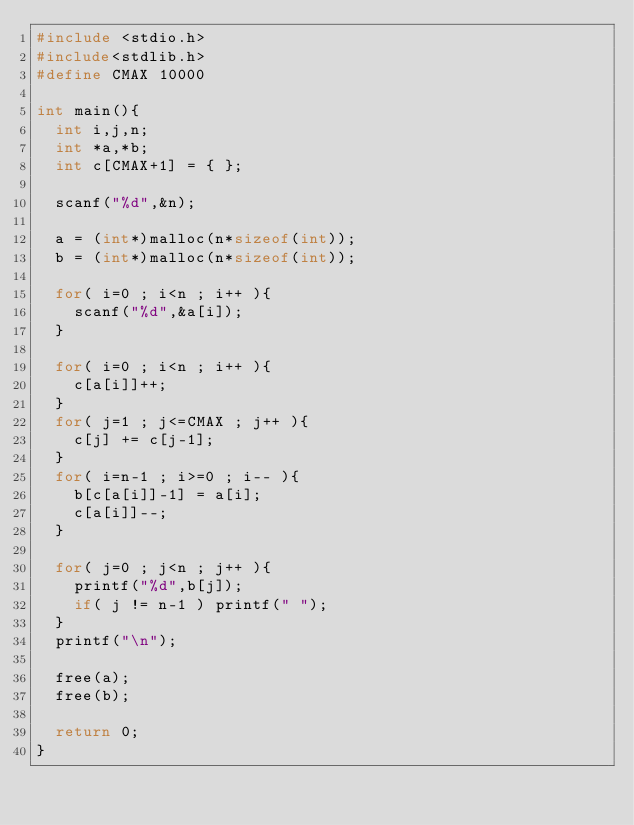Convert code to text. <code><loc_0><loc_0><loc_500><loc_500><_C++_>#include <stdio.h>
#include<stdlib.h>
#define CMAX 10000

int main(){
  int i,j,n;
  int *a,*b;
  int c[CMAX+1] = { };

  scanf("%d",&n);

  a = (int*)malloc(n*sizeof(int));
  b = (int*)malloc(n*sizeof(int));

  for( i=0 ; i<n ; i++ ){
    scanf("%d",&a[i]);
  }

  for( i=0 ; i<n ; i++ ){
    c[a[i]]++;
  }
  for( j=1 ; j<=CMAX ; j++ ){
    c[j] += c[j-1];
  }
  for( i=n-1 ; i>=0 ; i-- ){
    b[c[a[i]]-1] = a[i];
    c[a[i]]--;
  }
  
  for( j=0 ; j<n ; j++ ){
    printf("%d",b[j]);
    if( j != n-1 ) printf(" ");
  }
  printf("\n");

  free(a);
  free(b);

  return 0;
}</code> 